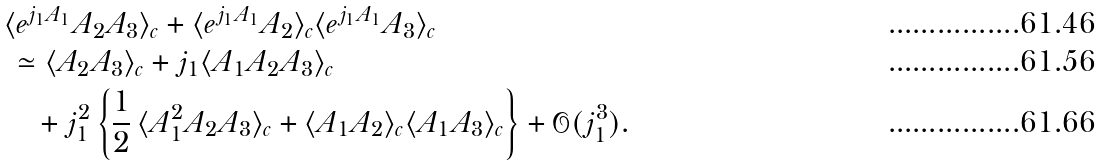<formula> <loc_0><loc_0><loc_500><loc_500>& \langle e ^ { j _ { 1 } A _ { 1 } } A _ { 2 } A _ { 3 } \rangle _ { c } + \langle e ^ { j _ { 1 } A _ { 1 } } A _ { 2 } \rangle _ { c } \langle e ^ { j _ { 1 } A _ { 1 } } A _ { 3 } \rangle _ { c } \\ & \, \simeq \langle A _ { 2 } A _ { 3 } \rangle _ { c } + j _ { 1 } \langle A _ { 1 } A _ { 2 } A _ { 3 } \rangle _ { c } \\ & \quad + j _ { 1 } ^ { 2 } \left \{ \frac { 1 } { 2 } \, \langle A _ { 1 } ^ { 2 } A _ { 2 } A _ { 3 } \rangle _ { c } + \langle A _ { 1 } A _ { 2 } \rangle _ { c } \langle A _ { 1 } A _ { 3 } \rangle _ { c } \right \} + \mathcal { O } ( j _ { 1 } ^ { 3 } ) .</formula> 